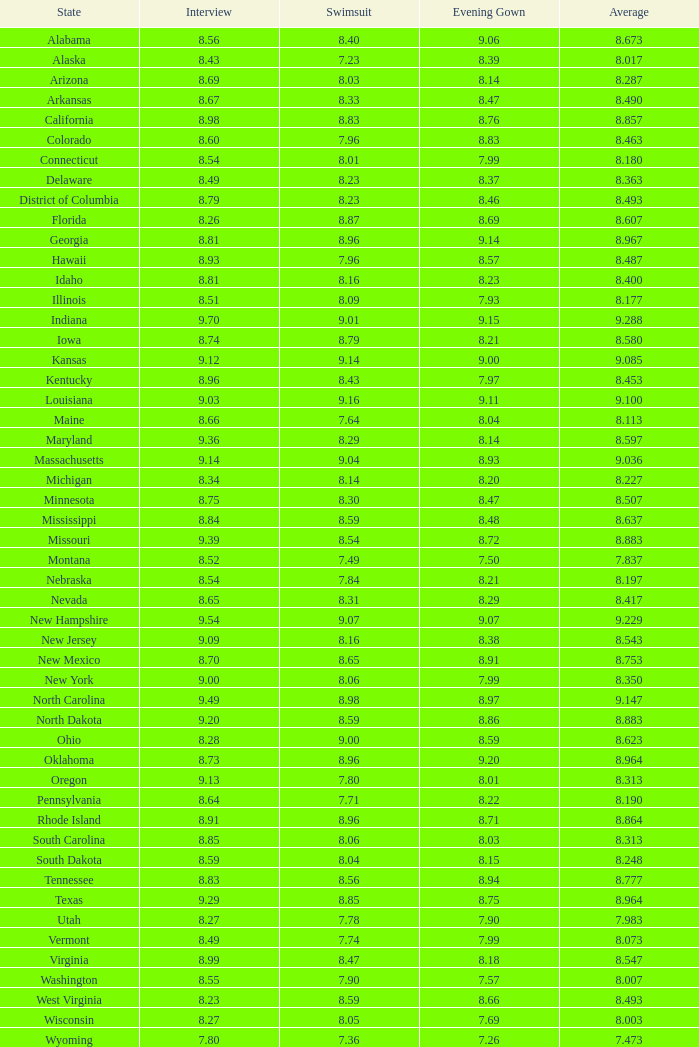Name the state with an evening gown more than 8.86 and interview less than 8.7 and swimsuit less than 8.96 Alabama. 